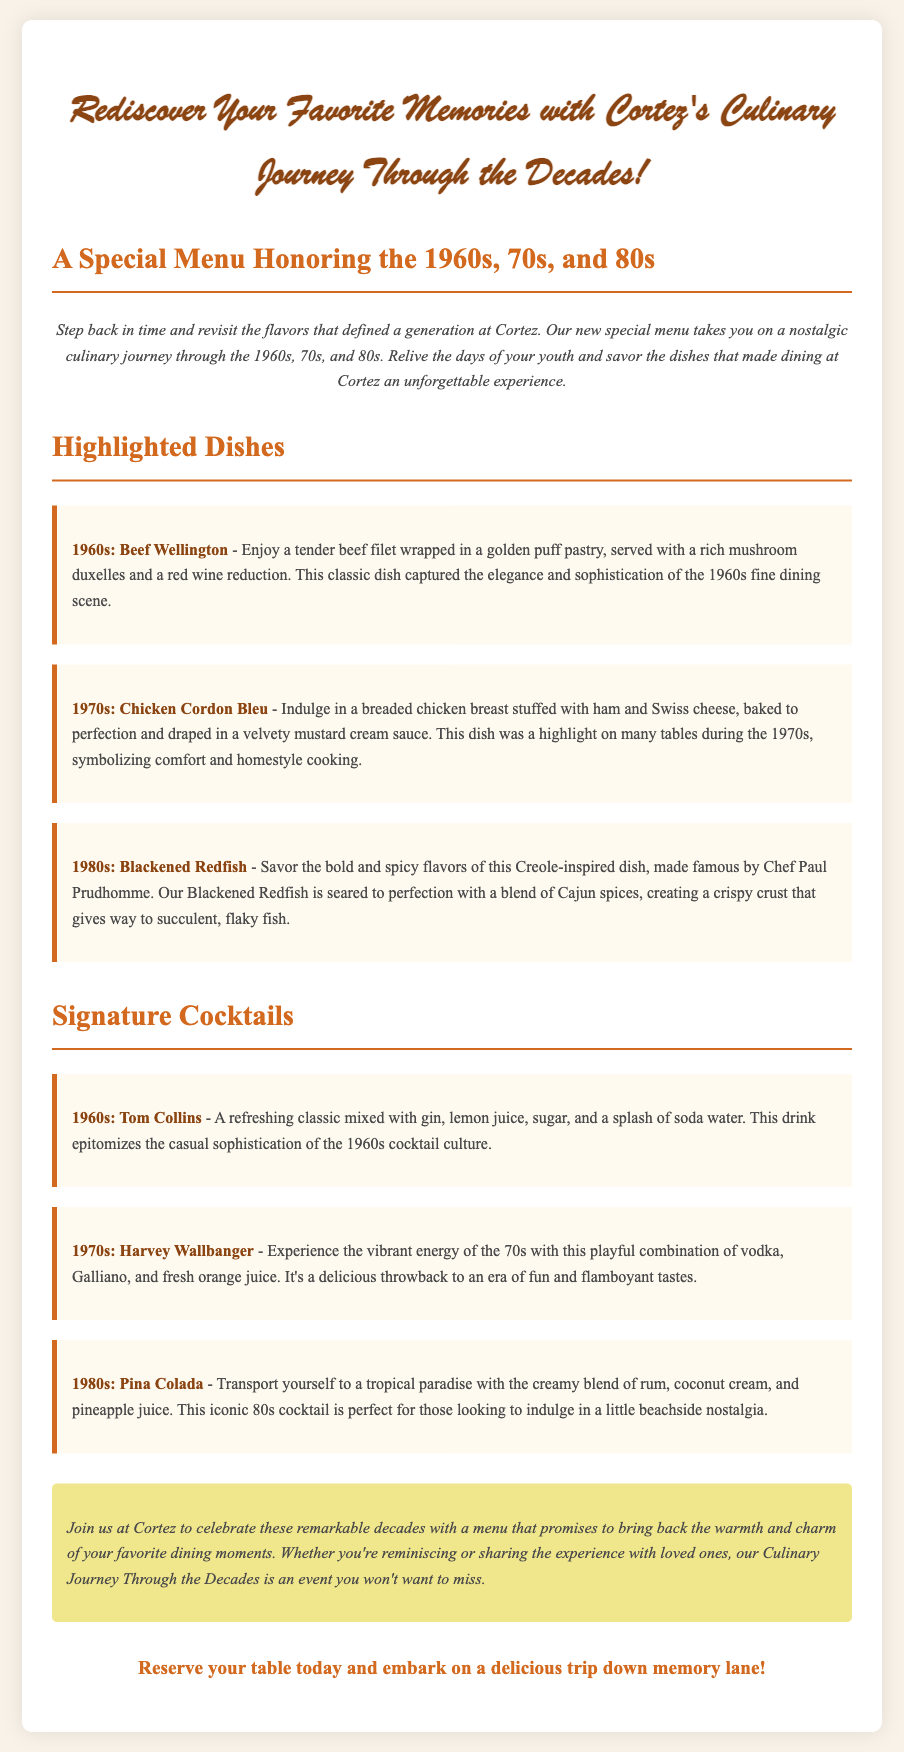What is the name of the special menu? The name of the special menu is highlighted in the title of the document, "Culinary Journey Through the Decades: A Special Menu at Cortez Honoring the 1960s, 70s, and 80s."
Answer: Culinary Journey Through the Decades What dish represents the 1960s? The document lists highlighted dishes for each decade, with Beef Wellington specifically mentioned for the 1960s.
Answer: Beef Wellington What is a signature cocktail from the 1980s? The cocktail mentioned for the 1980s is listed under the signature cocktails section of the document as Pina Colada.
Answer: Pina Colada How many decades does the special menu honor? The document references three decades specifically in the title, which are the 1960s, 70s, and 80s.
Answer: Three What dish symbolizes homestyle cooking from the 1970s? According to the description in the document, Chicken Cordon Bleu is highlighted for the 1970s and symbolizes comfort and homestyle cooking.
Answer: Chicken Cordon Bleu What type of drink is a Tom Collins? The document describes Tom Collins as a refreshing classic cocktail mixed with gin, lemon juice, sugar, and soda water.
Answer: Cocktail What sentiment does the special notes section convey? The special notes section expresses the charm and warmth of dining experiences in the highlighted decades, inviting guests to join Cortez for nostalgia.
Answer: Warmth and charm What should customers do to participate in the Culinary Journey? The document includes a call to action that encourages customers to reserve a table to join the event.
Answer: Reserve your table 